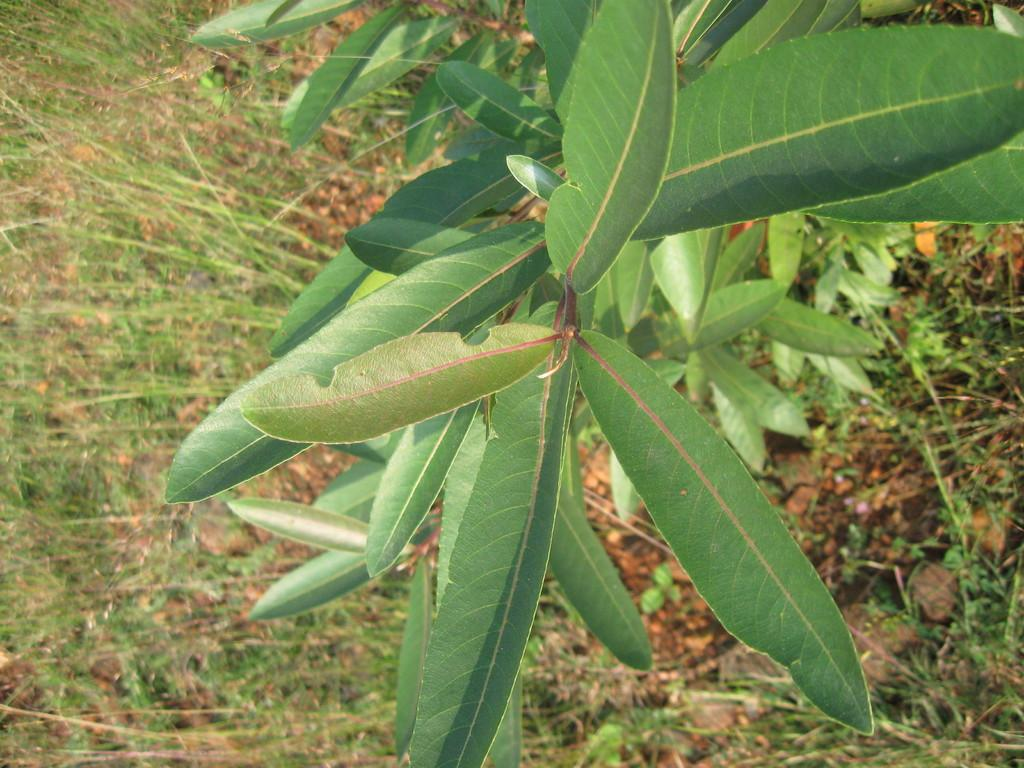What type of vegetation can be seen in the image? There are leaves in the image. What is the surface beneath the leaves? The ground is visible in the image. What type of plant is present in the image? There is grass in the image. What type of floor can be seen in the image? There is no floor present in the image; it features leaves, ground, and grass. How does the ant move around in the image? There are no ants present in the image. 